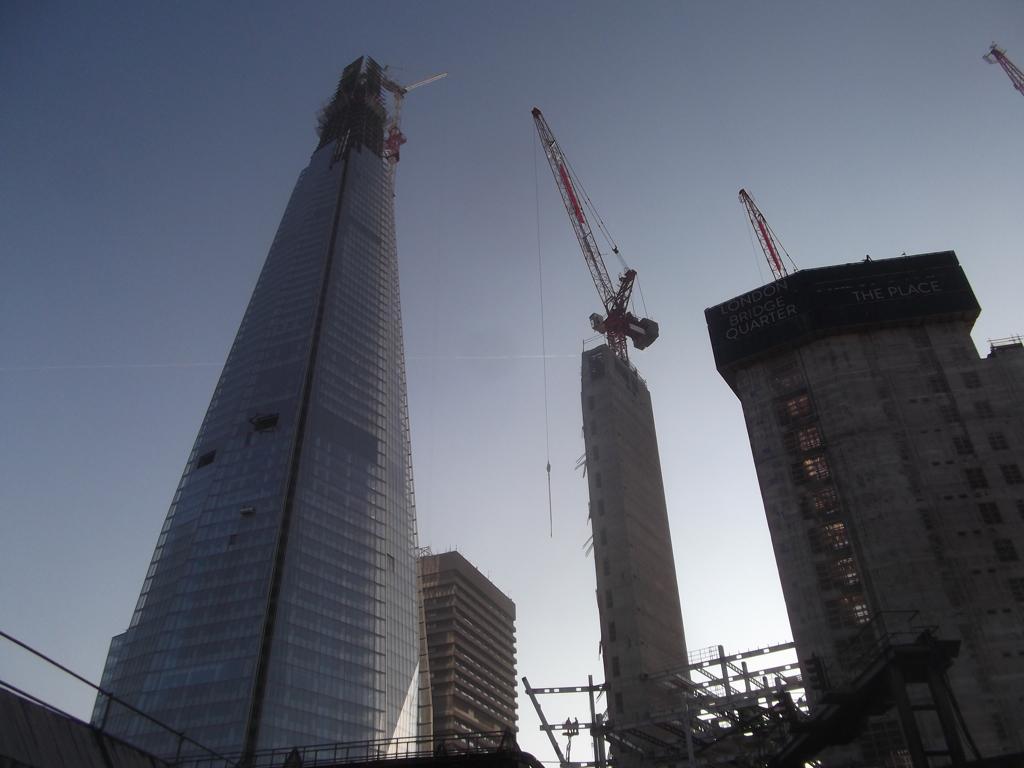Describe this image in one or two sentences. In this image we can see a few buildings, there are some cranes and metal rods, in the background, we can see the sky. 